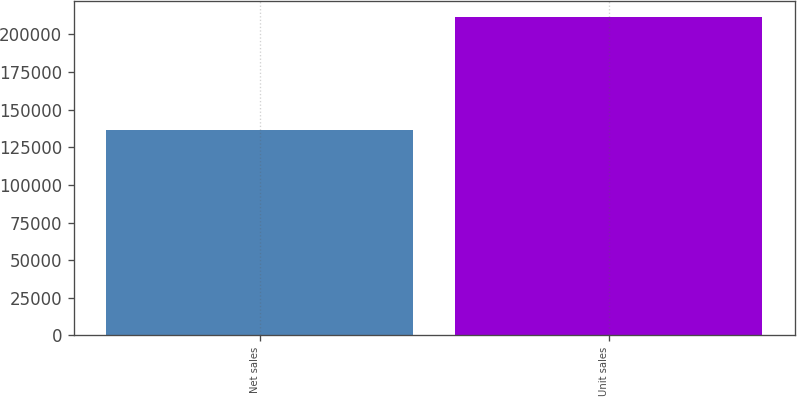Convert chart. <chart><loc_0><loc_0><loc_500><loc_500><bar_chart><fcel>Net sales<fcel>Unit sales<nl><fcel>136700<fcel>211884<nl></chart> 